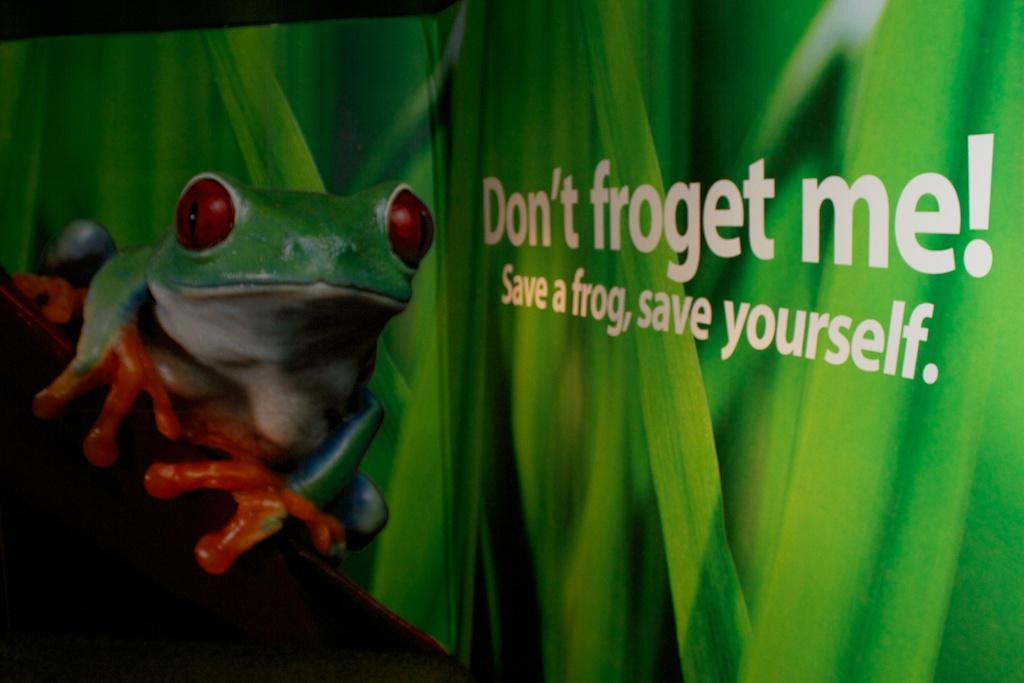What is featured on the poster in the picture? There is a poster in the picture, and it contains a picture of a frog. What color is the frog on the poster? The frog on the poster is in green color. What else can be seen on the poster besides the frog? There are plants depicted on the poster, and there is also text on the poster. Can you tell me how many cords are attached to the frog on the poster? There are no cords attached to the frog on the poster; it is a picture of a frog on a poster with plants and text. 